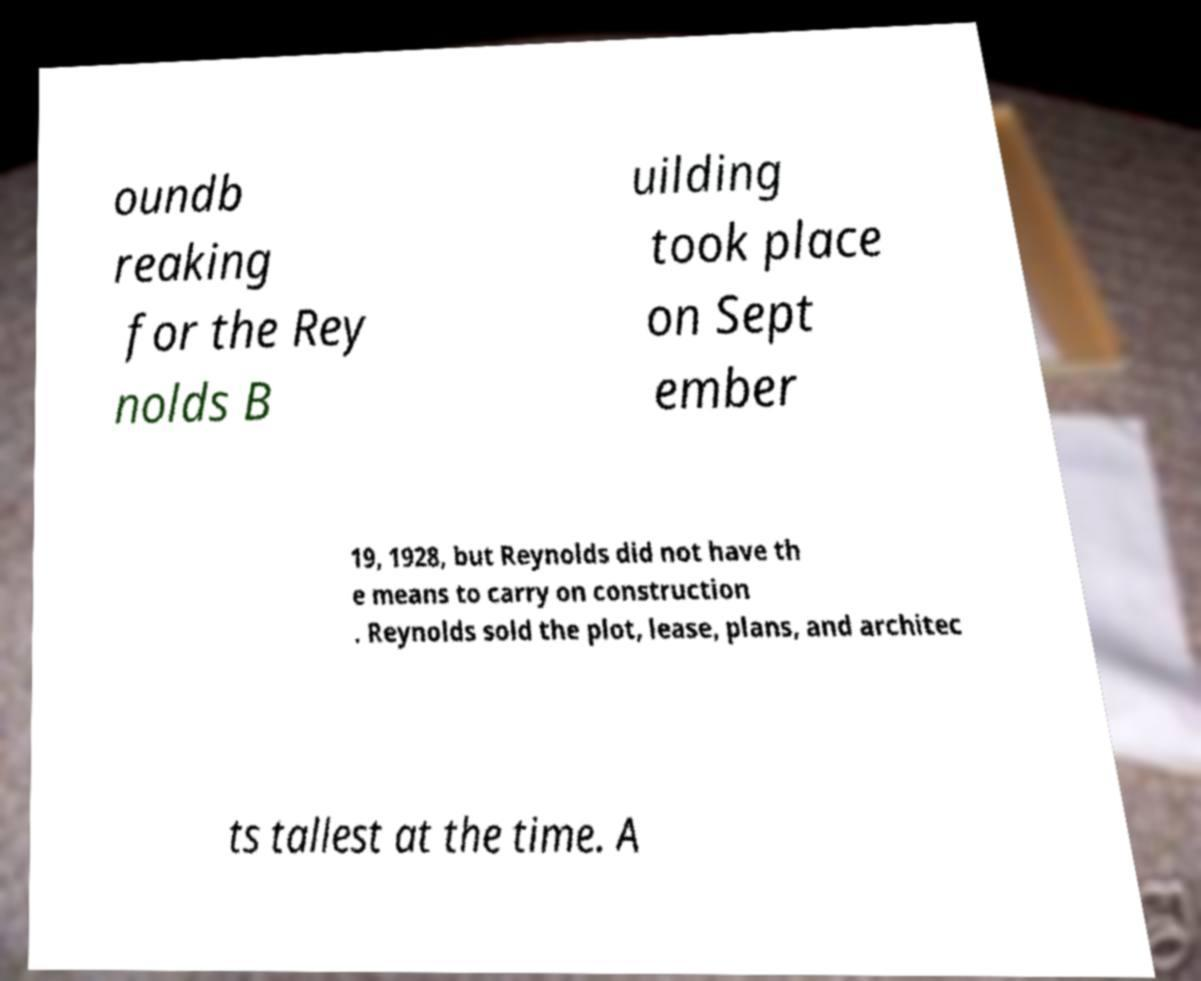Can you read and provide the text displayed in the image?This photo seems to have some interesting text. Can you extract and type it out for me? oundb reaking for the Rey nolds B uilding took place on Sept ember 19, 1928, but Reynolds did not have th e means to carry on construction . Reynolds sold the plot, lease, plans, and architec ts tallest at the time. A 